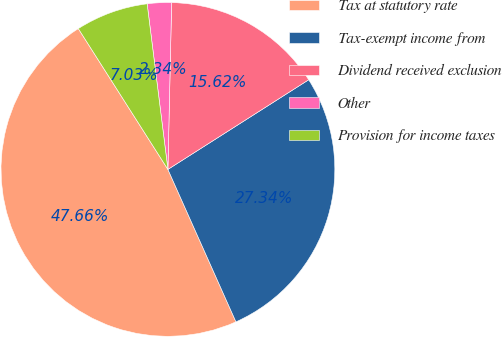Convert chart. <chart><loc_0><loc_0><loc_500><loc_500><pie_chart><fcel>Tax at statutory rate<fcel>Tax-exempt income from<fcel>Dividend received exclusion<fcel>Other<fcel>Provision for income taxes<nl><fcel>47.66%<fcel>27.34%<fcel>15.62%<fcel>2.34%<fcel>7.03%<nl></chart> 